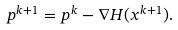<formula> <loc_0><loc_0><loc_500><loc_500>p ^ { k + 1 } = p ^ { k } - \nabla H ( x ^ { k + 1 } ) .</formula> 